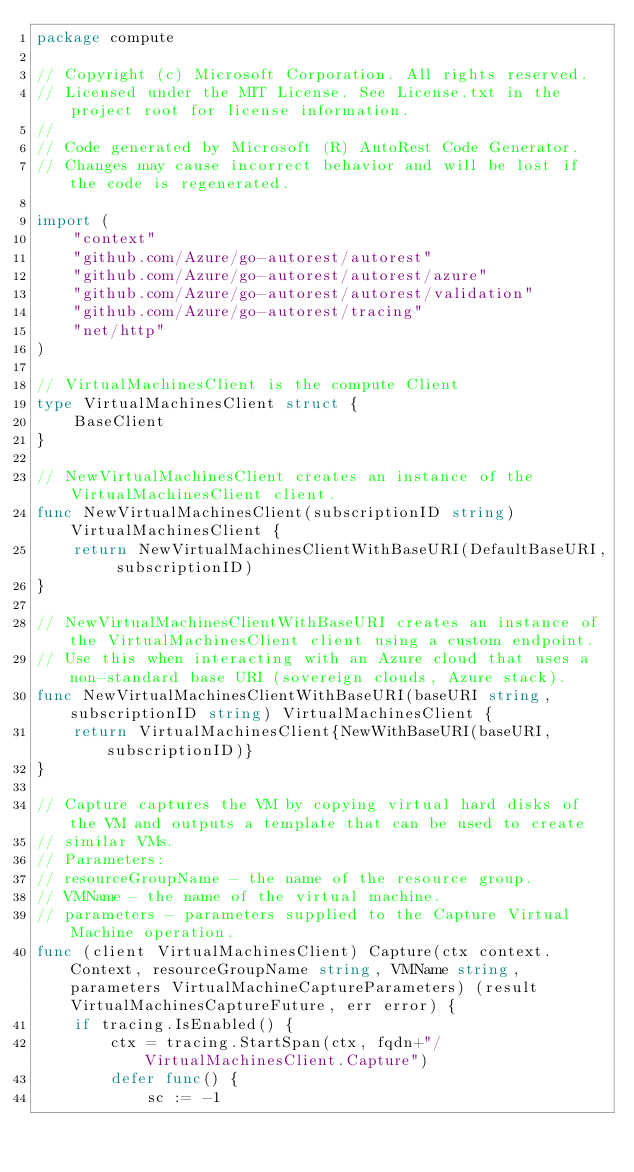Convert code to text. <code><loc_0><loc_0><loc_500><loc_500><_Go_>package compute

// Copyright (c) Microsoft Corporation. All rights reserved.
// Licensed under the MIT License. See License.txt in the project root for license information.
//
// Code generated by Microsoft (R) AutoRest Code Generator.
// Changes may cause incorrect behavior and will be lost if the code is regenerated.

import (
	"context"
	"github.com/Azure/go-autorest/autorest"
	"github.com/Azure/go-autorest/autorest/azure"
	"github.com/Azure/go-autorest/autorest/validation"
	"github.com/Azure/go-autorest/tracing"
	"net/http"
)

// VirtualMachinesClient is the compute Client
type VirtualMachinesClient struct {
	BaseClient
}

// NewVirtualMachinesClient creates an instance of the VirtualMachinesClient client.
func NewVirtualMachinesClient(subscriptionID string) VirtualMachinesClient {
	return NewVirtualMachinesClientWithBaseURI(DefaultBaseURI, subscriptionID)
}

// NewVirtualMachinesClientWithBaseURI creates an instance of the VirtualMachinesClient client using a custom endpoint.
// Use this when interacting with an Azure cloud that uses a non-standard base URI (sovereign clouds, Azure stack).
func NewVirtualMachinesClientWithBaseURI(baseURI string, subscriptionID string) VirtualMachinesClient {
	return VirtualMachinesClient{NewWithBaseURI(baseURI, subscriptionID)}
}

// Capture captures the VM by copying virtual hard disks of the VM and outputs a template that can be used to create
// similar VMs.
// Parameters:
// resourceGroupName - the name of the resource group.
// VMName - the name of the virtual machine.
// parameters - parameters supplied to the Capture Virtual Machine operation.
func (client VirtualMachinesClient) Capture(ctx context.Context, resourceGroupName string, VMName string, parameters VirtualMachineCaptureParameters) (result VirtualMachinesCaptureFuture, err error) {
	if tracing.IsEnabled() {
		ctx = tracing.StartSpan(ctx, fqdn+"/VirtualMachinesClient.Capture")
		defer func() {
			sc := -1</code> 